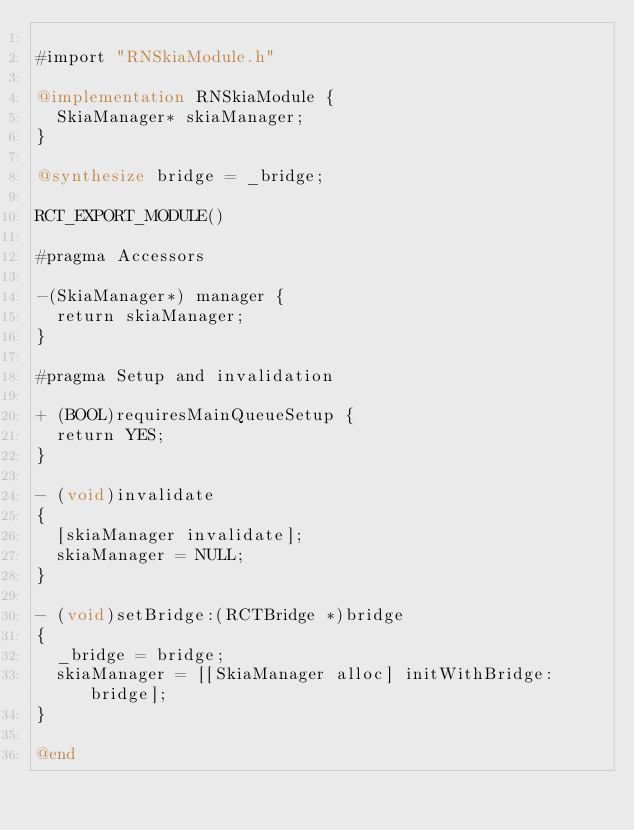<code> <loc_0><loc_0><loc_500><loc_500><_ObjectiveC_>
#import "RNSkiaModule.h"

@implementation RNSkiaModule {
  SkiaManager* skiaManager;
}

@synthesize bridge = _bridge;

RCT_EXPORT_MODULE()

#pragma Accessors

-(SkiaManager*) manager {
  return skiaManager;
}

#pragma Setup and invalidation

+ (BOOL)requiresMainQueueSetup {
  return YES;
}

- (void)invalidate
{
  [skiaManager invalidate];
  skiaManager = NULL;
}

- (void)setBridge:(RCTBridge *)bridge
{
  _bridge = bridge;
  skiaManager = [[SkiaManager alloc] initWithBridge:bridge];
}

@end
</code> 